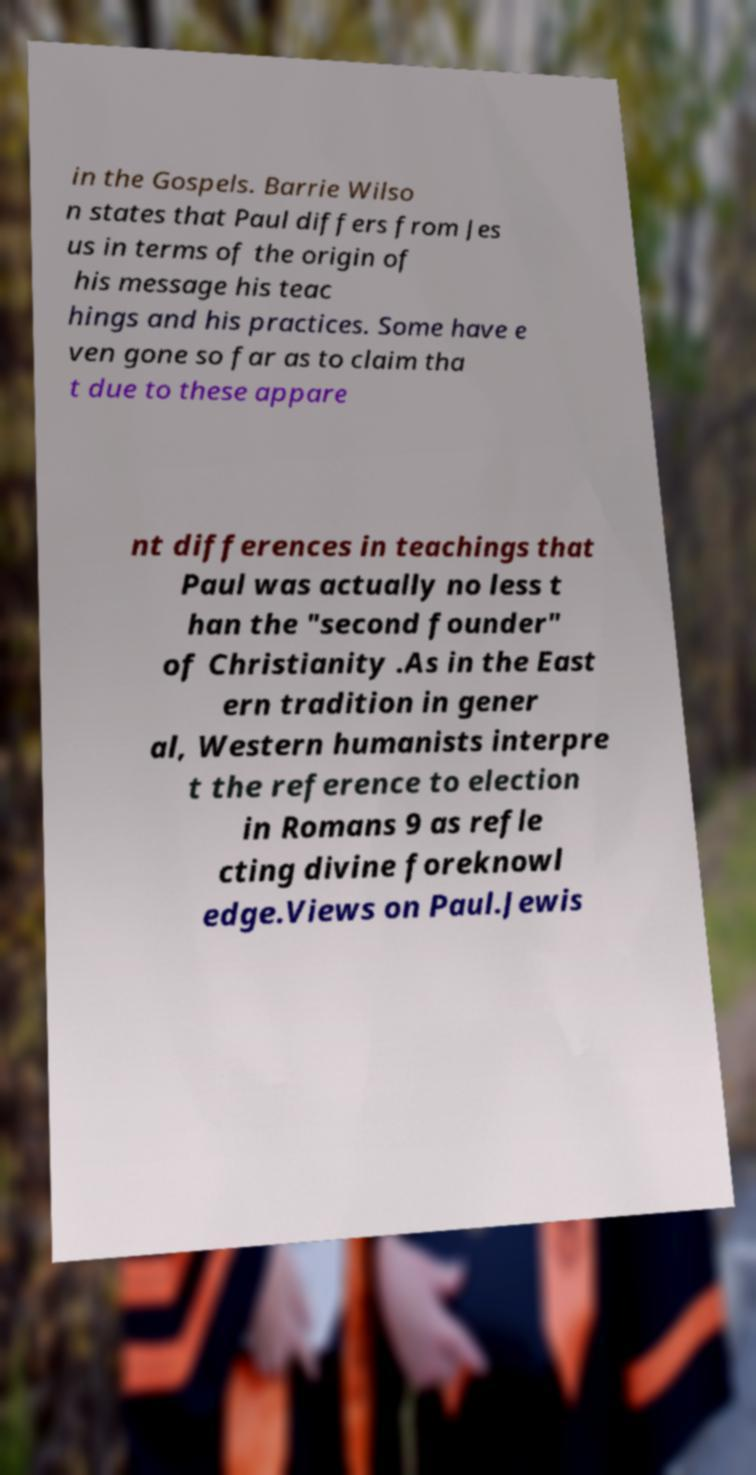There's text embedded in this image that I need extracted. Can you transcribe it verbatim? in the Gospels. Barrie Wilso n states that Paul differs from Jes us in terms of the origin of his message his teac hings and his practices. Some have e ven gone so far as to claim tha t due to these appare nt differences in teachings that Paul was actually no less t han the "second founder" of Christianity .As in the East ern tradition in gener al, Western humanists interpre t the reference to election in Romans 9 as refle cting divine foreknowl edge.Views on Paul.Jewis 